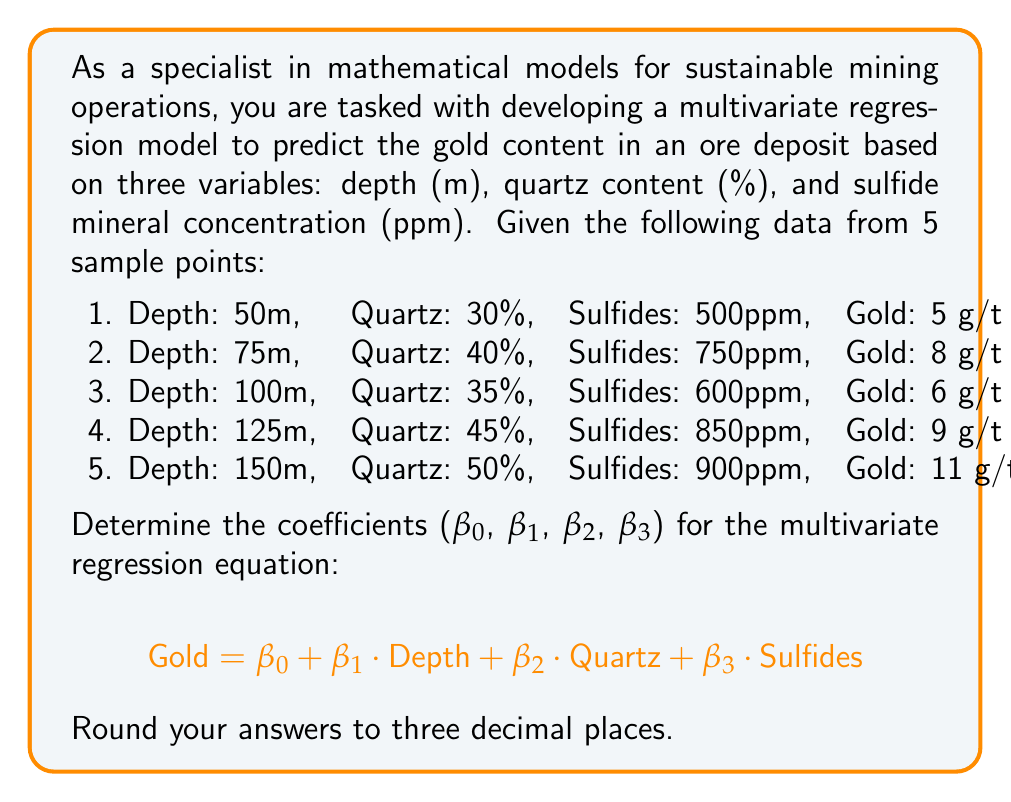Help me with this question. To solve this problem, we need to use the multivariate regression analysis. We'll use the matrix form of the least squares method:

$$ \beta = (X^T X)^{-1} X^T Y $$

Where:
- β is the vector of coefficients we're solving for
- X is the matrix of independent variables (including a column of 1's for the intercept)
- Y is the vector of dependent variables (Gold content)

Step 1: Set up the X matrix and Y vector

$$ X = \begin{bmatrix}
1 & 50 & 30 & 500 \\
1 & 75 & 40 & 750 \\
1 & 100 & 35 & 600 \\
1 & 125 & 45 & 850 \\
1 & 150 & 50 & 900
\end{bmatrix} $$

$$ Y = \begin{bmatrix}
5 \\
8 \\
6 \\
9 \\
11
\end{bmatrix} $$

Step 2: Calculate $X^T X$

$$ X^T X = \begin{bmatrix}
5 & 500 & 200 & 3600 \\
500 & 56250 & 21250 & 387500 \\
200 & 21250 & 8450 & 149000 \\
3600 & 387500 & 149000 & 2677500
\end{bmatrix} $$

Step 3: Calculate $(X^T X)^{-1}$
Using a calculator or computer software, we get:

$$ (X^T X)^{-1} = \begin{bmatrix}
13.069 & -0.077 & -0.223 & 0.003 \\
-0.077 & 0.001 & 0.001 & 0.000 \\
-0.223 & 0.001 & 0.007 & -0.001 \\
0.003 & 0.000 & -0.001 & 0.000
\end{bmatrix} $$

Step 4: Calculate $X^T Y$

$$ X^T Y = \begin{bmatrix}
39 \\
4325 \\
1665 \\
29850
\end{bmatrix} $$

Step 5: Calculate β = $(X^T X)^{-1} X^T Y$

$$ \beta = \begin{bmatrix}
13.069 & -0.077 & -0.223 & 0.003 \\
-0.077 & 0.001 & 0.001 & 0.000 \\
-0.223 & 0.001 & 0.007 & -0.001 \\
0.003 & 0.000 & -0.001 & 0.000
\end{bmatrix} \times \begin{bmatrix}
39 \\
4325 \\
1665 \\
29850
\end{bmatrix} $$

Performing this matrix multiplication gives us the coefficients β₀, β₁, β₂, and β₃.
Answer: The coefficients for the multivariate regression equation, rounded to three decimal places, are:

β₀ (Intercept) = -4.183
β₁ (Depth) = 0.033
β₂ (Quartz) = 0.157
β₃ (Sulfides) = 0.005

Therefore, the multivariate regression equation is:

$$ \text{Gold} = -4.183 + 0.033 \cdot \text{Depth} + 0.157 \cdot \text{Quartz} + 0.005 \cdot \text{Sulfides} $$ 